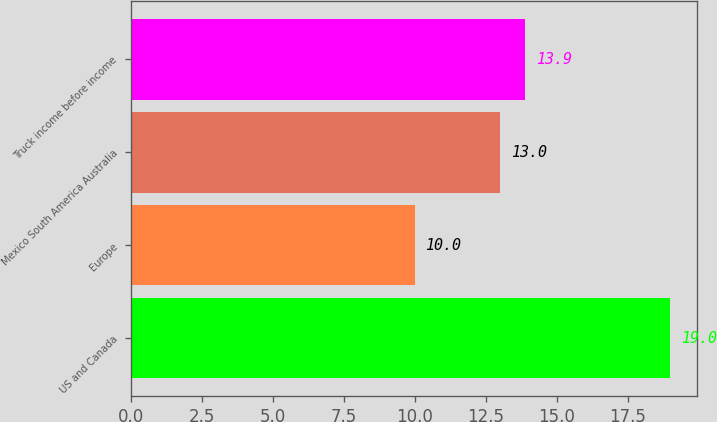<chart> <loc_0><loc_0><loc_500><loc_500><bar_chart><fcel>US and Canada<fcel>Europe<fcel>Mexico South America Australia<fcel>Truck income before income<nl><fcel>19<fcel>10<fcel>13<fcel>13.9<nl></chart> 